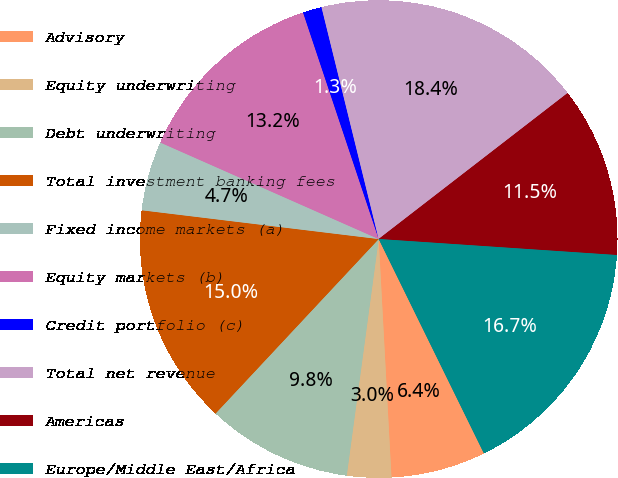Convert chart. <chart><loc_0><loc_0><loc_500><loc_500><pie_chart><fcel>Advisory<fcel>Equity underwriting<fcel>Debt underwriting<fcel>Total investment banking fees<fcel>Fixed income markets (a)<fcel>Equity markets (b)<fcel>Credit portfolio (c)<fcel>Total net revenue<fcel>Americas<fcel>Europe/Middle East/Africa<nl><fcel>6.41%<fcel>2.99%<fcel>9.83%<fcel>14.96%<fcel>4.7%<fcel>13.25%<fcel>1.28%<fcel>18.38%<fcel>11.54%<fcel>16.67%<nl></chart> 